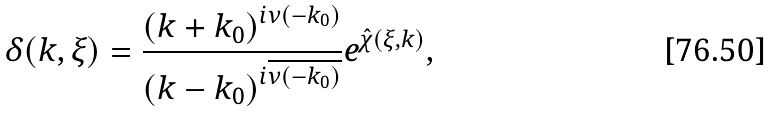Convert formula to latex. <formula><loc_0><loc_0><loc_500><loc_500>\delta ( k , \xi ) = \frac { \left ( k + k _ { 0 } \right ) ^ { i \nu ( - k _ { 0 } ) } } { \left ( k - k _ { 0 } \right ) ^ { i \overline { \nu ( - k _ { 0 } ) } } } e ^ { \hat { \chi } ( \xi , k ) } ,</formula> 